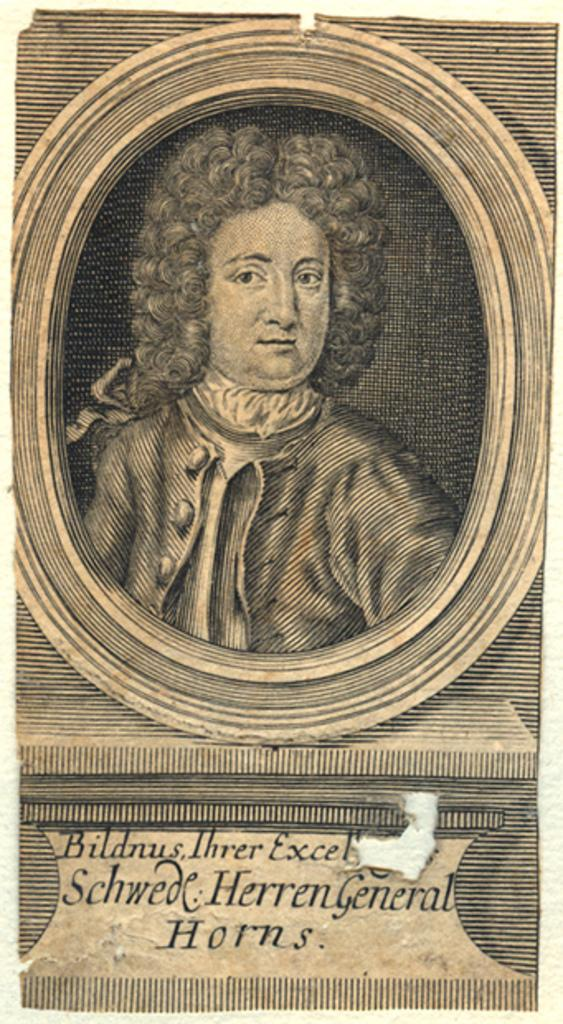<image>
Give a short and clear explanation of the subsequent image. The engraving depicts a man named Herren General Horns. 